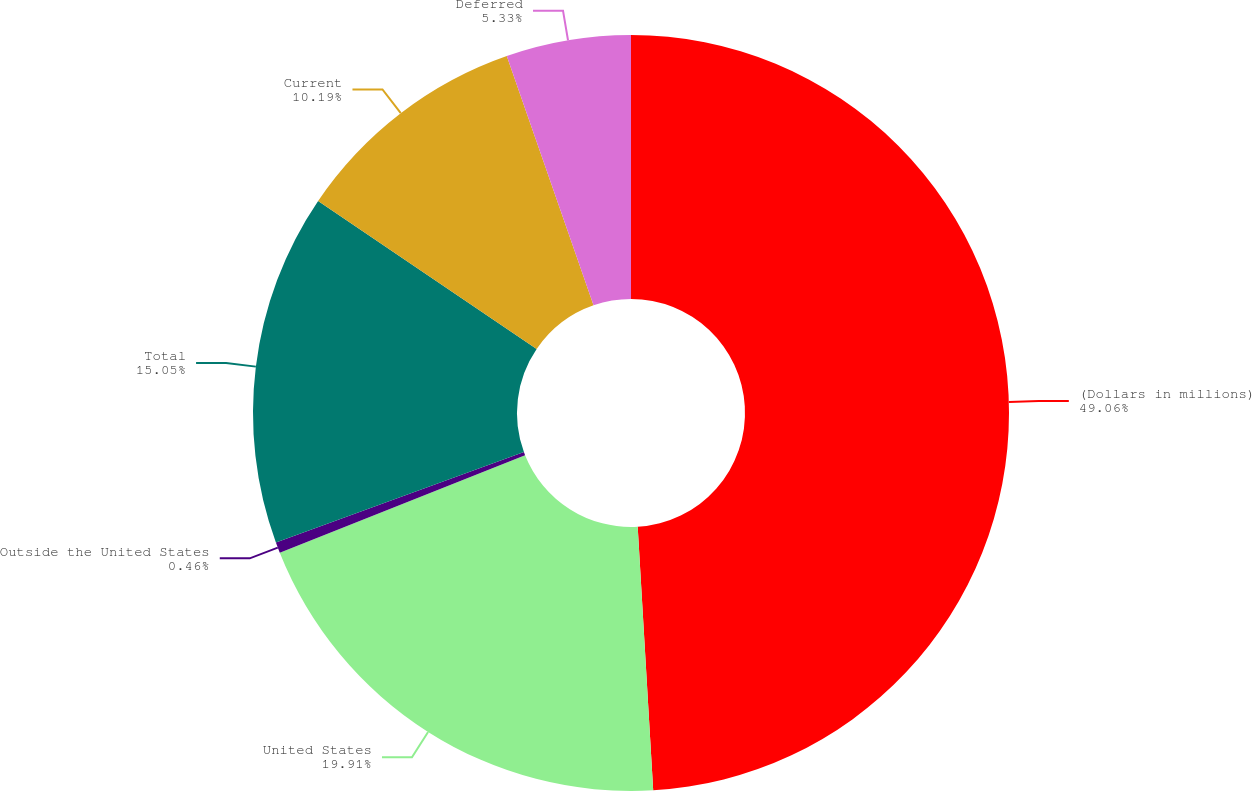Convert chart. <chart><loc_0><loc_0><loc_500><loc_500><pie_chart><fcel>(Dollars in millions)<fcel>United States<fcel>Outside the United States<fcel>Total<fcel>Current<fcel>Deferred<nl><fcel>49.07%<fcel>19.91%<fcel>0.46%<fcel>15.05%<fcel>10.19%<fcel>5.33%<nl></chart> 